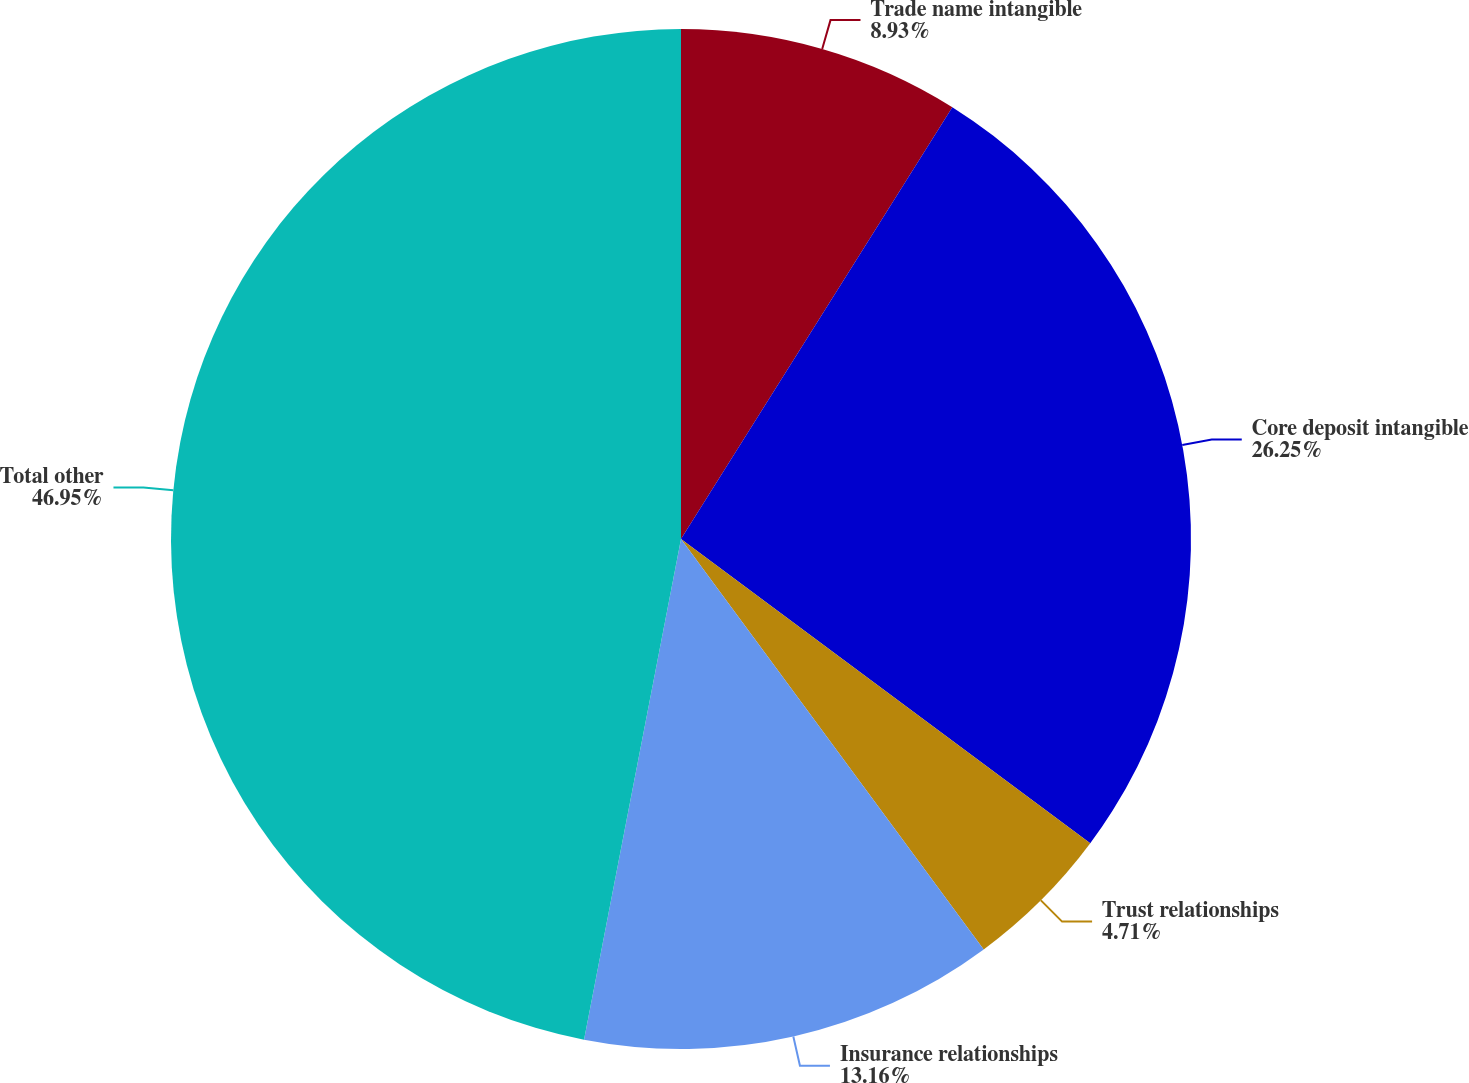Convert chart to OTSL. <chart><loc_0><loc_0><loc_500><loc_500><pie_chart><fcel>Trade name intangible<fcel>Core deposit intangible<fcel>Trust relationships<fcel>Insurance relationships<fcel>Total other<nl><fcel>8.93%<fcel>26.25%<fcel>4.71%<fcel>13.16%<fcel>46.96%<nl></chart> 